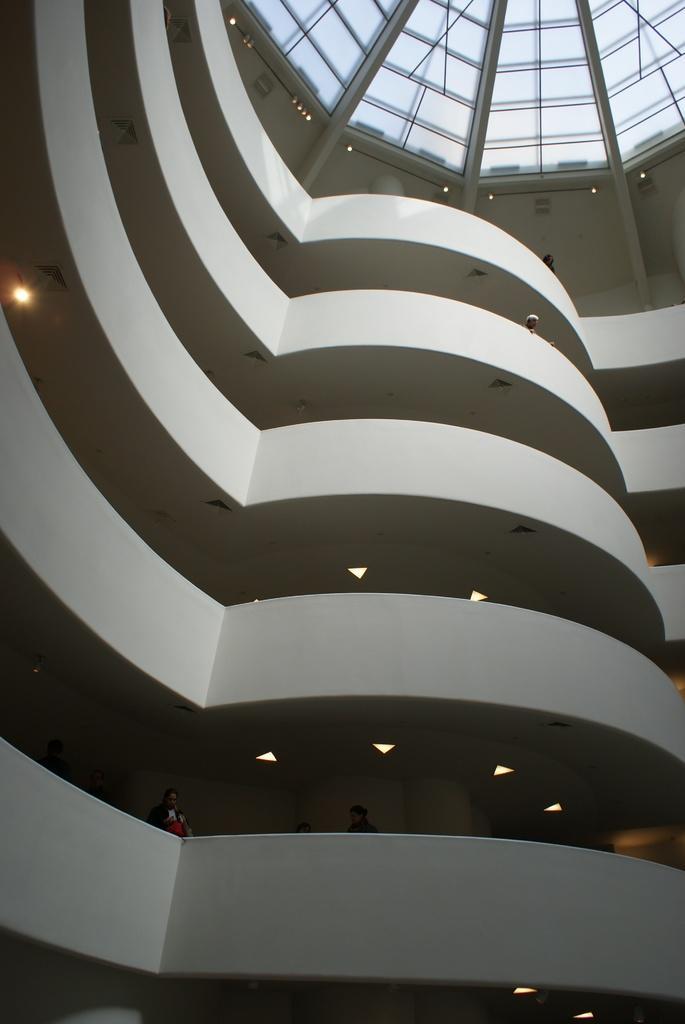Describe this image in one or two sentences. In the image inside the building there are many floors with walls and lights. And also there are few people. At the top of the image there is a ceiling with glass roofs and lights. 